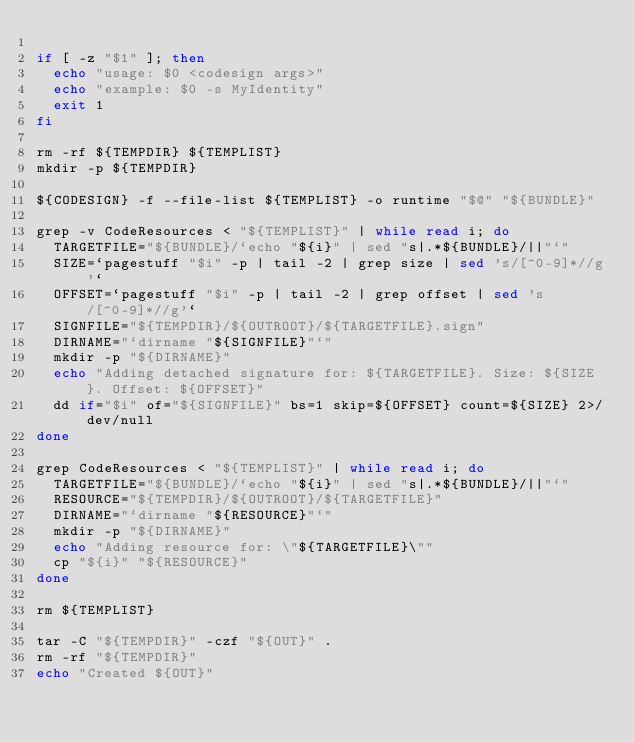Convert code to text. <code><loc_0><loc_0><loc_500><loc_500><_Bash_>
if [ -z "$1" ]; then
  echo "usage: $0 <codesign args>"
  echo "example: $0 -s MyIdentity"
  exit 1
fi

rm -rf ${TEMPDIR} ${TEMPLIST}
mkdir -p ${TEMPDIR}

${CODESIGN} -f --file-list ${TEMPLIST} -o runtime "$@" "${BUNDLE}"

grep -v CodeResources < "${TEMPLIST}" | while read i; do
  TARGETFILE="${BUNDLE}/`echo "${i}" | sed "s|.*${BUNDLE}/||"`"
  SIZE=`pagestuff "$i" -p | tail -2 | grep size | sed 's/[^0-9]*//g'`
  OFFSET=`pagestuff "$i" -p | tail -2 | grep offset | sed 's/[^0-9]*//g'`
  SIGNFILE="${TEMPDIR}/${OUTROOT}/${TARGETFILE}.sign"
  DIRNAME="`dirname "${SIGNFILE}"`"
  mkdir -p "${DIRNAME}"
  echo "Adding detached signature for: ${TARGETFILE}. Size: ${SIZE}. Offset: ${OFFSET}"
  dd if="$i" of="${SIGNFILE}" bs=1 skip=${OFFSET} count=${SIZE} 2>/dev/null
done

grep CodeResources < "${TEMPLIST}" | while read i; do
  TARGETFILE="${BUNDLE}/`echo "${i}" | sed "s|.*${BUNDLE}/||"`"
  RESOURCE="${TEMPDIR}/${OUTROOT}/${TARGETFILE}"
  DIRNAME="`dirname "${RESOURCE}"`"
  mkdir -p "${DIRNAME}"
  echo "Adding resource for: \"${TARGETFILE}\""
  cp "${i}" "${RESOURCE}"
done

rm ${TEMPLIST}

tar -C "${TEMPDIR}" -czf "${OUT}" .
rm -rf "${TEMPDIR}"
echo "Created ${OUT}"
</code> 